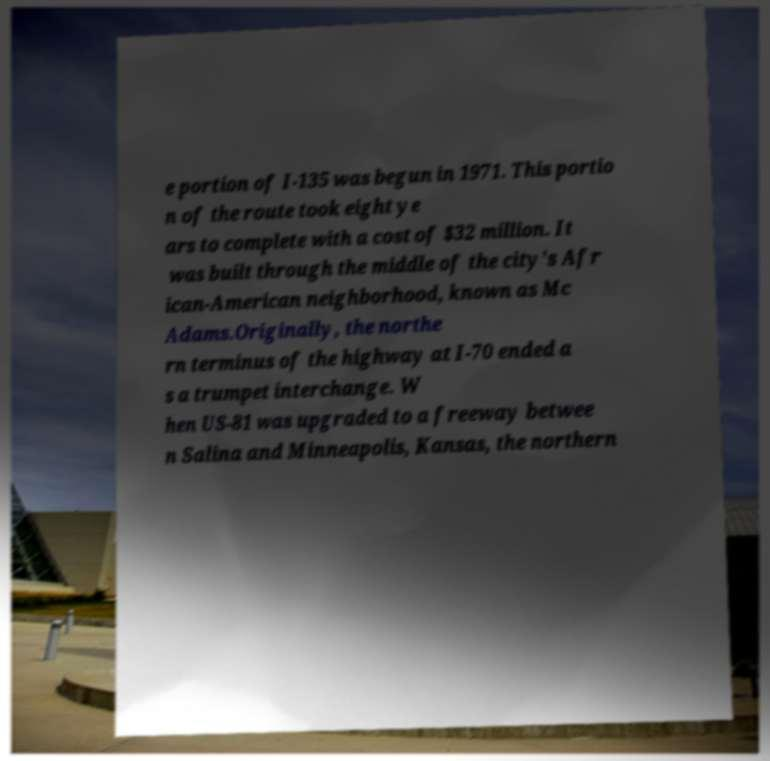Could you extract and type out the text from this image? e portion of I-135 was begun in 1971. This portio n of the route took eight ye ars to complete with a cost of $32 million. It was built through the middle of the city's Afr ican-American neighborhood, known as Mc Adams.Originally, the northe rn terminus of the highway at I-70 ended a s a trumpet interchange. W hen US-81 was upgraded to a freeway betwee n Salina and Minneapolis, Kansas, the northern 